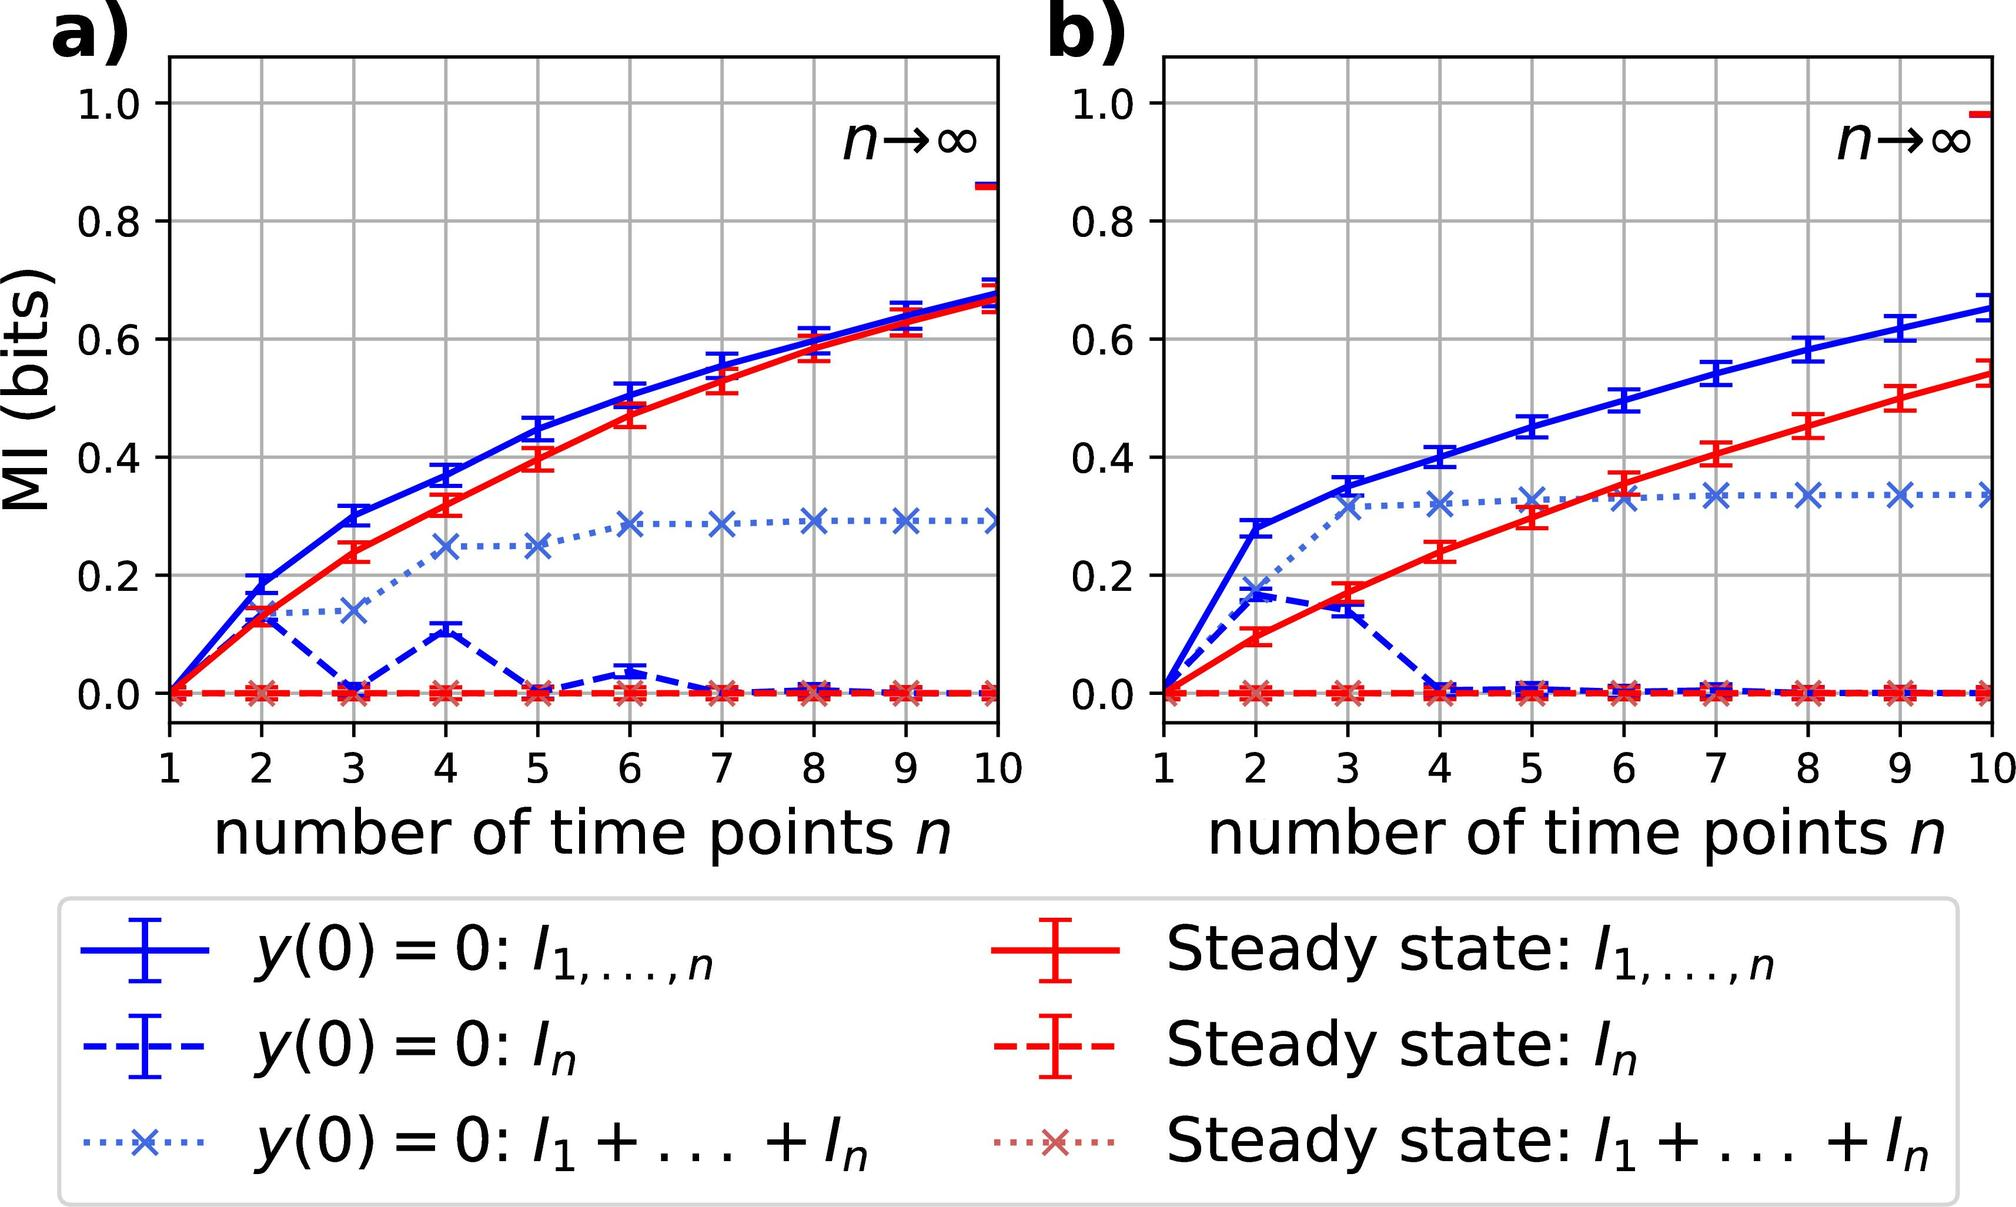What can we deduce about the system's complexity from the MI graphs? The complexity of the system being studied can be inferred from the MI graphs based on the rate and pattern of MI increase. A steep increase in MI as the number of time points grows would suggest a system with intricate dynamics, where each new time point adds a significant amount of new information about the system's state. Conversely, a system that exhibits a flattening MI curve, like the one labeled \( y(0) = 0: I_1 + \ldots + I_n \) in figure a), suggests a less complex or more predictable system where additional time points do not contribute much new information. The complexity of interactions within the system and its predictability are thus reflected in these MI trends. 